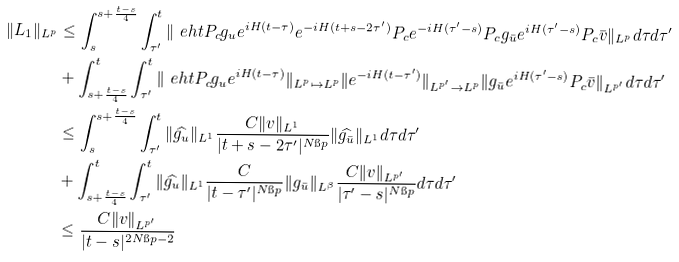Convert formula to latex. <formula><loc_0><loc_0><loc_500><loc_500>\| L _ { 1 } \| _ { L ^ { p } } & \leq \int _ { s } ^ { s + \frac { t - s } { 4 } } \int _ { \tau ^ { \prime } } ^ { t } \| \ e h t P _ { c } g _ { u } e ^ { i H ( t - \tau ) } e ^ { - i H ( t + s - 2 \tau ^ { \prime } ) } P _ { c } e ^ { - i H ( \tau ^ { \prime } - s ) } P _ { c } g _ { \bar { u } } e ^ { i H ( \tau ^ { \prime } - s ) } P _ { c } \bar { v } \| _ { L ^ { p } } d \tau d \tau ^ { \prime } \\ & + \int _ { s + \frac { t - s } { 4 } } ^ { t } \int _ { \tau ^ { \prime } } ^ { t } \| \ e h t P _ { c } g _ { u } e ^ { i H ( t - \tau ) } \| _ { L ^ { p } \mapsto L ^ { p } } \| e ^ { - i H ( t - \tau ^ { \prime } ) } \| _ { L ^ { p ^ { \prime } } \rightarrow L ^ { p } } \| g _ { \bar { u } } e ^ { i H ( \tau ^ { \prime } - s ) } P _ { c } \bar { v } \| _ { L ^ { p ^ { \prime } } } d \tau d \tau ^ { \prime } \\ & \leq \int _ { s } ^ { s + \frac { t - s } { 4 } } \int _ { \tau ^ { \prime } } ^ { t } \| \widehat { g _ { u } } \| _ { L ^ { 1 } } \frac { C \| v \| _ { L ^ { 1 } } } { | t + s - 2 \tau ^ { \prime } | ^ { N \i p } } \| \widehat { g _ { \bar { u } } } \| _ { L ^ { 1 } } d \tau d \tau ^ { \prime } \\ & + \int _ { s + \frac { t - s } { 4 } } ^ { t } \int _ { \tau ^ { \prime } } ^ { t } \| \widehat { g _ { u } } \| _ { L ^ { 1 } } \frac { C } { | t - \tau ^ { \prime } | ^ { N \i p } } \| g _ { \bar { u } } \| _ { L ^ { \beta } } \frac { C \| v \| _ { L ^ { p ^ { \prime } } } } { | \tau ^ { \prime } - s | ^ { N \i p } } d \tau d \tau ^ { \prime } \\ & \leq \frac { C \| v \| _ { L ^ { p ^ { \prime } } } } { | t - s | ^ { 2 N \i p - 2 } }</formula> 